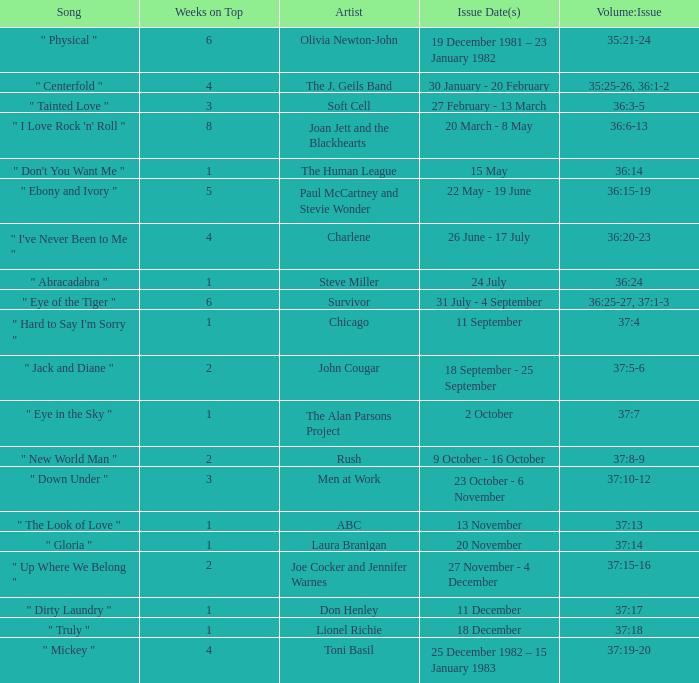Which Issue Date(s) has Weeks on Top larger than 3, and a Volume: Issue of 35:25-26, 36:1-2? 30 January - 20 February. 